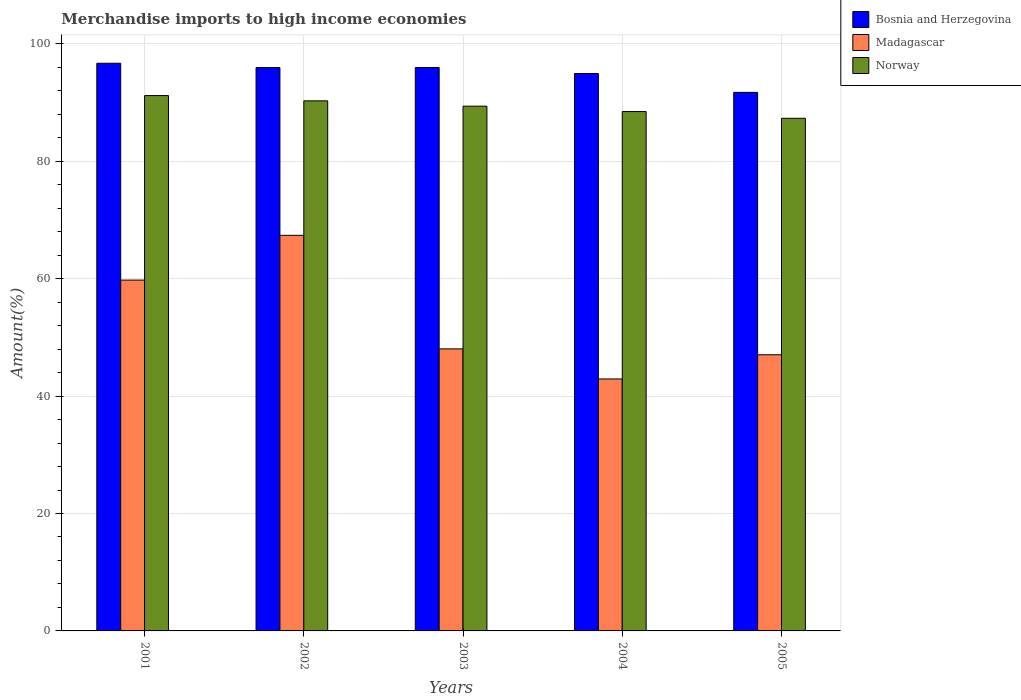How many different coloured bars are there?
Your answer should be compact. 3. Are the number of bars per tick equal to the number of legend labels?
Your answer should be very brief. Yes. In how many cases, is the number of bars for a given year not equal to the number of legend labels?
Make the answer very short. 0. What is the percentage of amount earned from merchandise imports in Norway in 2005?
Give a very brief answer. 87.31. Across all years, what is the maximum percentage of amount earned from merchandise imports in Madagascar?
Keep it short and to the point. 67.38. Across all years, what is the minimum percentage of amount earned from merchandise imports in Bosnia and Herzegovina?
Ensure brevity in your answer.  91.72. In which year was the percentage of amount earned from merchandise imports in Bosnia and Herzegovina maximum?
Give a very brief answer. 2001. In which year was the percentage of amount earned from merchandise imports in Madagascar minimum?
Provide a succinct answer. 2004. What is the total percentage of amount earned from merchandise imports in Bosnia and Herzegovina in the graph?
Your response must be concise. 475.24. What is the difference between the percentage of amount earned from merchandise imports in Bosnia and Herzegovina in 2002 and that in 2004?
Give a very brief answer. 1. What is the difference between the percentage of amount earned from merchandise imports in Madagascar in 2005 and the percentage of amount earned from merchandise imports in Norway in 2002?
Give a very brief answer. -43.25. What is the average percentage of amount earned from merchandise imports in Bosnia and Herzegovina per year?
Your answer should be very brief. 95.05. In the year 2004, what is the difference between the percentage of amount earned from merchandise imports in Bosnia and Herzegovina and percentage of amount earned from merchandise imports in Madagascar?
Your response must be concise. 52.02. What is the ratio of the percentage of amount earned from merchandise imports in Norway in 2001 to that in 2002?
Ensure brevity in your answer.  1.01. Is the percentage of amount earned from merchandise imports in Madagascar in 2001 less than that in 2003?
Ensure brevity in your answer.  No. Is the difference between the percentage of amount earned from merchandise imports in Bosnia and Herzegovina in 2003 and 2005 greater than the difference between the percentage of amount earned from merchandise imports in Madagascar in 2003 and 2005?
Offer a very short reply. Yes. What is the difference between the highest and the second highest percentage of amount earned from merchandise imports in Madagascar?
Offer a terse response. 7.63. What is the difference between the highest and the lowest percentage of amount earned from merchandise imports in Norway?
Give a very brief answer. 3.87. In how many years, is the percentage of amount earned from merchandise imports in Madagascar greater than the average percentage of amount earned from merchandise imports in Madagascar taken over all years?
Your answer should be compact. 2. Is the sum of the percentage of amount earned from merchandise imports in Madagascar in 2003 and 2005 greater than the maximum percentage of amount earned from merchandise imports in Norway across all years?
Your answer should be very brief. Yes. What does the 2nd bar from the left in 2004 represents?
Provide a succinct answer. Madagascar. How many bars are there?
Your answer should be compact. 15. How many years are there in the graph?
Give a very brief answer. 5. Does the graph contain any zero values?
Give a very brief answer. No. Does the graph contain grids?
Make the answer very short. Yes. Where does the legend appear in the graph?
Make the answer very short. Top right. How many legend labels are there?
Ensure brevity in your answer.  3. What is the title of the graph?
Offer a very short reply. Merchandise imports to high income economies. What is the label or title of the Y-axis?
Ensure brevity in your answer.  Amount(%). What is the Amount(%) of Bosnia and Herzegovina in 2001?
Offer a terse response. 96.68. What is the Amount(%) in Madagascar in 2001?
Offer a very short reply. 59.75. What is the Amount(%) of Norway in 2001?
Provide a short and direct response. 91.18. What is the Amount(%) of Bosnia and Herzegovina in 2002?
Offer a very short reply. 95.94. What is the Amount(%) in Madagascar in 2002?
Your response must be concise. 67.38. What is the Amount(%) in Norway in 2002?
Offer a terse response. 90.28. What is the Amount(%) of Bosnia and Herzegovina in 2003?
Offer a very short reply. 95.96. What is the Amount(%) of Madagascar in 2003?
Offer a terse response. 48.03. What is the Amount(%) of Norway in 2003?
Your answer should be very brief. 89.37. What is the Amount(%) in Bosnia and Herzegovina in 2004?
Offer a terse response. 94.94. What is the Amount(%) in Madagascar in 2004?
Provide a succinct answer. 42.91. What is the Amount(%) in Norway in 2004?
Ensure brevity in your answer.  88.46. What is the Amount(%) of Bosnia and Herzegovina in 2005?
Your response must be concise. 91.72. What is the Amount(%) of Madagascar in 2005?
Your answer should be very brief. 47.03. What is the Amount(%) of Norway in 2005?
Make the answer very short. 87.31. Across all years, what is the maximum Amount(%) in Bosnia and Herzegovina?
Give a very brief answer. 96.68. Across all years, what is the maximum Amount(%) of Madagascar?
Keep it short and to the point. 67.38. Across all years, what is the maximum Amount(%) in Norway?
Make the answer very short. 91.18. Across all years, what is the minimum Amount(%) in Bosnia and Herzegovina?
Your answer should be very brief. 91.72. Across all years, what is the minimum Amount(%) in Madagascar?
Give a very brief answer. 42.91. Across all years, what is the minimum Amount(%) of Norway?
Give a very brief answer. 87.31. What is the total Amount(%) in Bosnia and Herzegovina in the graph?
Ensure brevity in your answer.  475.24. What is the total Amount(%) in Madagascar in the graph?
Make the answer very short. 265.11. What is the total Amount(%) of Norway in the graph?
Make the answer very short. 446.6. What is the difference between the Amount(%) of Bosnia and Herzegovina in 2001 and that in 2002?
Provide a succinct answer. 0.74. What is the difference between the Amount(%) of Madagascar in 2001 and that in 2002?
Provide a succinct answer. -7.63. What is the difference between the Amount(%) in Norway in 2001 and that in 2002?
Give a very brief answer. 0.9. What is the difference between the Amount(%) of Bosnia and Herzegovina in 2001 and that in 2003?
Your answer should be very brief. 0.72. What is the difference between the Amount(%) in Madagascar in 2001 and that in 2003?
Your answer should be compact. 11.72. What is the difference between the Amount(%) in Norway in 2001 and that in 2003?
Your response must be concise. 1.81. What is the difference between the Amount(%) in Bosnia and Herzegovina in 2001 and that in 2004?
Offer a terse response. 1.74. What is the difference between the Amount(%) of Madagascar in 2001 and that in 2004?
Keep it short and to the point. 16.84. What is the difference between the Amount(%) of Norway in 2001 and that in 2004?
Provide a succinct answer. 2.72. What is the difference between the Amount(%) in Bosnia and Herzegovina in 2001 and that in 2005?
Make the answer very short. 4.96. What is the difference between the Amount(%) in Madagascar in 2001 and that in 2005?
Offer a terse response. 12.72. What is the difference between the Amount(%) of Norway in 2001 and that in 2005?
Keep it short and to the point. 3.87. What is the difference between the Amount(%) in Bosnia and Herzegovina in 2002 and that in 2003?
Your answer should be compact. -0.02. What is the difference between the Amount(%) in Madagascar in 2002 and that in 2003?
Offer a very short reply. 19.34. What is the difference between the Amount(%) of Norway in 2002 and that in 2003?
Offer a very short reply. 0.9. What is the difference between the Amount(%) of Madagascar in 2002 and that in 2004?
Your answer should be compact. 24.46. What is the difference between the Amount(%) in Norway in 2002 and that in 2004?
Your response must be concise. 1.82. What is the difference between the Amount(%) in Bosnia and Herzegovina in 2002 and that in 2005?
Provide a short and direct response. 4.22. What is the difference between the Amount(%) of Madagascar in 2002 and that in 2005?
Ensure brevity in your answer.  20.34. What is the difference between the Amount(%) of Norway in 2002 and that in 2005?
Your answer should be compact. 2.97. What is the difference between the Amount(%) of Bosnia and Herzegovina in 2003 and that in 2004?
Your answer should be very brief. 1.02. What is the difference between the Amount(%) in Madagascar in 2003 and that in 2004?
Your answer should be compact. 5.12. What is the difference between the Amount(%) in Norway in 2003 and that in 2004?
Provide a succinct answer. 0.92. What is the difference between the Amount(%) in Bosnia and Herzegovina in 2003 and that in 2005?
Provide a short and direct response. 4.24. What is the difference between the Amount(%) of Norway in 2003 and that in 2005?
Your answer should be compact. 2.06. What is the difference between the Amount(%) of Bosnia and Herzegovina in 2004 and that in 2005?
Keep it short and to the point. 3.22. What is the difference between the Amount(%) in Madagascar in 2004 and that in 2005?
Provide a short and direct response. -4.12. What is the difference between the Amount(%) in Norway in 2004 and that in 2005?
Ensure brevity in your answer.  1.15. What is the difference between the Amount(%) of Bosnia and Herzegovina in 2001 and the Amount(%) of Madagascar in 2002?
Ensure brevity in your answer.  29.31. What is the difference between the Amount(%) of Bosnia and Herzegovina in 2001 and the Amount(%) of Norway in 2002?
Your answer should be very brief. 6.4. What is the difference between the Amount(%) of Madagascar in 2001 and the Amount(%) of Norway in 2002?
Offer a very short reply. -30.53. What is the difference between the Amount(%) in Bosnia and Herzegovina in 2001 and the Amount(%) in Madagascar in 2003?
Your answer should be compact. 48.65. What is the difference between the Amount(%) of Bosnia and Herzegovina in 2001 and the Amount(%) of Norway in 2003?
Your answer should be compact. 7.31. What is the difference between the Amount(%) of Madagascar in 2001 and the Amount(%) of Norway in 2003?
Provide a short and direct response. -29.62. What is the difference between the Amount(%) in Bosnia and Herzegovina in 2001 and the Amount(%) in Madagascar in 2004?
Your answer should be compact. 53.77. What is the difference between the Amount(%) of Bosnia and Herzegovina in 2001 and the Amount(%) of Norway in 2004?
Ensure brevity in your answer.  8.23. What is the difference between the Amount(%) of Madagascar in 2001 and the Amount(%) of Norway in 2004?
Offer a terse response. -28.71. What is the difference between the Amount(%) of Bosnia and Herzegovina in 2001 and the Amount(%) of Madagascar in 2005?
Keep it short and to the point. 49.65. What is the difference between the Amount(%) in Bosnia and Herzegovina in 2001 and the Amount(%) in Norway in 2005?
Give a very brief answer. 9.37. What is the difference between the Amount(%) in Madagascar in 2001 and the Amount(%) in Norway in 2005?
Your response must be concise. -27.56. What is the difference between the Amount(%) in Bosnia and Herzegovina in 2002 and the Amount(%) in Madagascar in 2003?
Your answer should be very brief. 47.91. What is the difference between the Amount(%) in Bosnia and Herzegovina in 2002 and the Amount(%) in Norway in 2003?
Your answer should be very brief. 6.57. What is the difference between the Amount(%) of Madagascar in 2002 and the Amount(%) of Norway in 2003?
Provide a short and direct response. -22. What is the difference between the Amount(%) of Bosnia and Herzegovina in 2002 and the Amount(%) of Madagascar in 2004?
Ensure brevity in your answer.  53.03. What is the difference between the Amount(%) in Bosnia and Herzegovina in 2002 and the Amount(%) in Norway in 2004?
Provide a short and direct response. 7.49. What is the difference between the Amount(%) of Madagascar in 2002 and the Amount(%) of Norway in 2004?
Your answer should be compact. -21.08. What is the difference between the Amount(%) in Bosnia and Herzegovina in 2002 and the Amount(%) in Madagascar in 2005?
Keep it short and to the point. 48.91. What is the difference between the Amount(%) of Bosnia and Herzegovina in 2002 and the Amount(%) of Norway in 2005?
Your answer should be compact. 8.63. What is the difference between the Amount(%) of Madagascar in 2002 and the Amount(%) of Norway in 2005?
Your answer should be very brief. -19.93. What is the difference between the Amount(%) in Bosnia and Herzegovina in 2003 and the Amount(%) in Madagascar in 2004?
Provide a succinct answer. 53.05. What is the difference between the Amount(%) of Bosnia and Herzegovina in 2003 and the Amount(%) of Norway in 2004?
Provide a succinct answer. 7.5. What is the difference between the Amount(%) in Madagascar in 2003 and the Amount(%) in Norway in 2004?
Offer a terse response. -40.42. What is the difference between the Amount(%) in Bosnia and Herzegovina in 2003 and the Amount(%) in Madagascar in 2005?
Provide a succinct answer. 48.93. What is the difference between the Amount(%) in Bosnia and Herzegovina in 2003 and the Amount(%) in Norway in 2005?
Keep it short and to the point. 8.65. What is the difference between the Amount(%) of Madagascar in 2003 and the Amount(%) of Norway in 2005?
Ensure brevity in your answer.  -39.28. What is the difference between the Amount(%) in Bosnia and Herzegovina in 2004 and the Amount(%) in Madagascar in 2005?
Offer a terse response. 47.91. What is the difference between the Amount(%) in Bosnia and Herzegovina in 2004 and the Amount(%) in Norway in 2005?
Your answer should be very brief. 7.63. What is the difference between the Amount(%) in Madagascar in 2004 and the Amount(%) in Norway in 2005?
Make the answer very short. -44.4. What is the average Amount(%) of Bosnia and Herzegovina per year?
Your answer should be very brief. 95.05. What is the average Amount(%) of Madagascar per year?
Provide a succinct answer. 53.02. What is the average Amount(%) in Norway per year?
Offer a terse response. 89.32. In the year 2001, what is the difference between the Amount(%) in Bosnia and Herzegovina and Amount(%) in Madagascar?
Keep it short and to the point. 36.93. In the year 2001, what is the difference between the Amount(%) in Bosnia and Herzegovina and Amount(%) in Norway?
Make the answer very short. 5.5. In the year 2001, what is the difference between the Amount(%) in Madagascar and Amount(%) in Norway?
Provide a short and direct response. -31.43. In the year 2002, what is the difference between the Amount(%) of Bosnia and Herzegovina and Amount(%) of Madagascar?
Your answer should be very brief. 28.57. In the year 2002, what is the difference between the Amount(%) in Bosnia and Herzegovina and Amount(%) in Norway?
Your answer should be very brief. 5.66. In the year 2002, what is the difference between the Amount(%) of Madagascar and Amount(%) of Norway?
Give a very brief answer. -22.9. In the year 2003, what is the difference between the Amount(%) in Bosnia and Herzegovina and Amount(%) in Madagascar?
Provide a short and direct response. 47.93. In the year 2003, what is the difference between the Amount(%) of Bosnia and Herzegovina and Amount(%) of Norway?
Offer a very short reply. 6.59. In the year 2003, what is the difference between the Amount(%) in Madagascar and Amount(%) in Norway?
Your response must be concise. -41.34. In the year 2004, what is the difference between the Amount(%) of Bosnia and Herzegovina and Amount(%) of Madagascar?
Ensure brevity in your answer.  52.02. In the year 2004, what is the difference between the Amount(%) of Bosnia and Herzegovina and Amount(%) of Norway?
Provide a succinct answer. 6.48. In the year 2004, what is the difference between the Amount(%) of Madagascar and Amount(%) of Norway?
Give a very brief answer. -45.54. In the year 2005, what is the difference between the Amount(%) in Bosnia and Herzegovina and Amount(%) in Madagascar?
Your response must be concise. 44.69. In the year 2005, what is the difference between the Amount(%) of Bosnia and Herzegovina and Amount(%) of Norway?
Provide a short and direct response. 4.41. In the year 2005, what is the difference between the Amount(%) in Madagascar and Amount(%) in Norway?
Keep it short and to the point. -40.28. What is the ratio of the Amount(%) of Bosnia and Herzegovina in 2001 to that in 2002?
Give a very brief answer. 1.01. What is the ratio of the Amount(%) in Madagascar in 2001 to that in 2002?
Your answer should be compact. 0.89. What is the ratio of the Amount(%) in Bosnia and Herzegovina in 2001 to that in 2003?
Keep it short and to the point. 1.01. What is the ratio of the Amount(%) of Madagascar in 2001 to that in 2003?
Provide a succinct answer. 1.24. What is the ratio of the Amount(%) in Norway in 2001 to that in 2003?
Your answer should be compact. 1.02. What is the ratio of the Amount(%) in Bosnia and Herzegovina in 2001 to that in 2004?
Ensure brevity in your answer.  1.02. What is the ratio of the Amount(%) in Madagascar in 2001 to that in 2004?
Offer a very short reply. 1.39. What is the ratio of the Amount(%) in Norway in 2001 to that in 2004?
Your answer should be very brief. 1.03. What is the ratio of the Amount(%) of Bosnia and Herzegovina in 2001 to that in 2005?
Keep it short and to the point. 1.05. What is the ratio of the Amount(%) in Madagascar in 2001 to that in 2005?
Your answer should be very brief. 1.27. What is the ratio of the Amount(%) of Norway in 2001 to that in 2005?
Your answer should be very brief. 1.04. What is the ratio of the Amount(%) of Madagascar in 2002 to that in 2003?
Give a very brief answer. 1.4. What is the ratio of the Amount(%) in Bosnia and Herzegovina in 2002 to that in 2004?
Make the answer very short. 1.01. What is the ratio of the Amount(%) of Madagascar in 2002 to that in 2004?
Make the answer very short. 1.57. What is the ratio of the Amount(%) of Norway in 2002 to that in 2004?
Ensure brevity in your answer.  1.02. What is the ratio of the Amount(%) in Bosnia and Herzegovina in 2002 to that in 2005?
Provide a short and direct response. 1.05. What is the ratio of the Amount(%) in Madagascar in 2002 to that in 2005?
Offer a terse response. 1.43. What is the ratio of the Amount(%) in Norway in 2002 to that in 2005?
Provide a succinct answer. 1.03. What is the ratio of the Amount(%) in Bosnia and Herzegovina in 2003 to that in 2004?
Ensure brevity in your answer.  1.01. What is the ratio of the Amount(%) of Madagascar in 2003 to that in 2004?
Your response must be concise. 1.12. What is the ratio of the Amount(%) in Norway in 2003 to that in 2004?
Give a very brief answer. 1.01. What is the ratio of the Amount(%) in Bosnia and Herzegovina in 2003 to that in 2005?
Keep it short and to the point. 1.05. What is the ratio of the Amount(%) in Madagascar in 2003 to that in 2005?
Offer a very short reply. 1.02. What is the ratio of the Amount(%) in Norway in 2003 to that in 2005?
Your answer should be compact. 1.02. What is the ratio of the Amount(%) of Bosnia and Herzegovina in 2004 to that in 2005?
Offer a very short reply. 1.04. What is the ratio of the Amount(%) in Madagascar in 2004 to that in 2005?
Provide a succinct answer. 0.91. What is the ratio of the Amount(%) of Norway in 2004 to that in 2005?
Make the answer very short. 1.01. What is the difference between the highest and the second highest Amount(%) in Bosnia and Herzegovina?
Make the answer very short. 0.72. What is the difference between the highest and the second highest Amount(%) in Madagascar?
Provide a short and direct response. 7.63. What is the difference between the highest and the second highest Amount(%) in Norway?
Give a very brief answer. 0.9. What is the difference between the highest and the lowest Amount(%) of Bosnia and Herzegovina?
Make the answer very short. 4.96. What is the difference between the highest and the lowest Amount(%) of Madagascar?
Make the answer very short. 24.46. What is the difference between the highest and the lowest Amount(%) of Norway?
Ensure brevity in your answer.  3.87. 